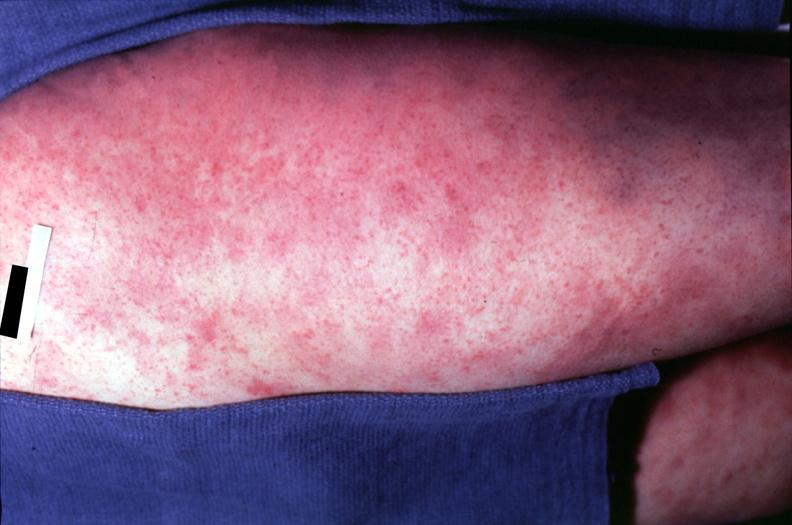what is rocky mountain spotted?
Answer the question using a single word or phrase. Fever 